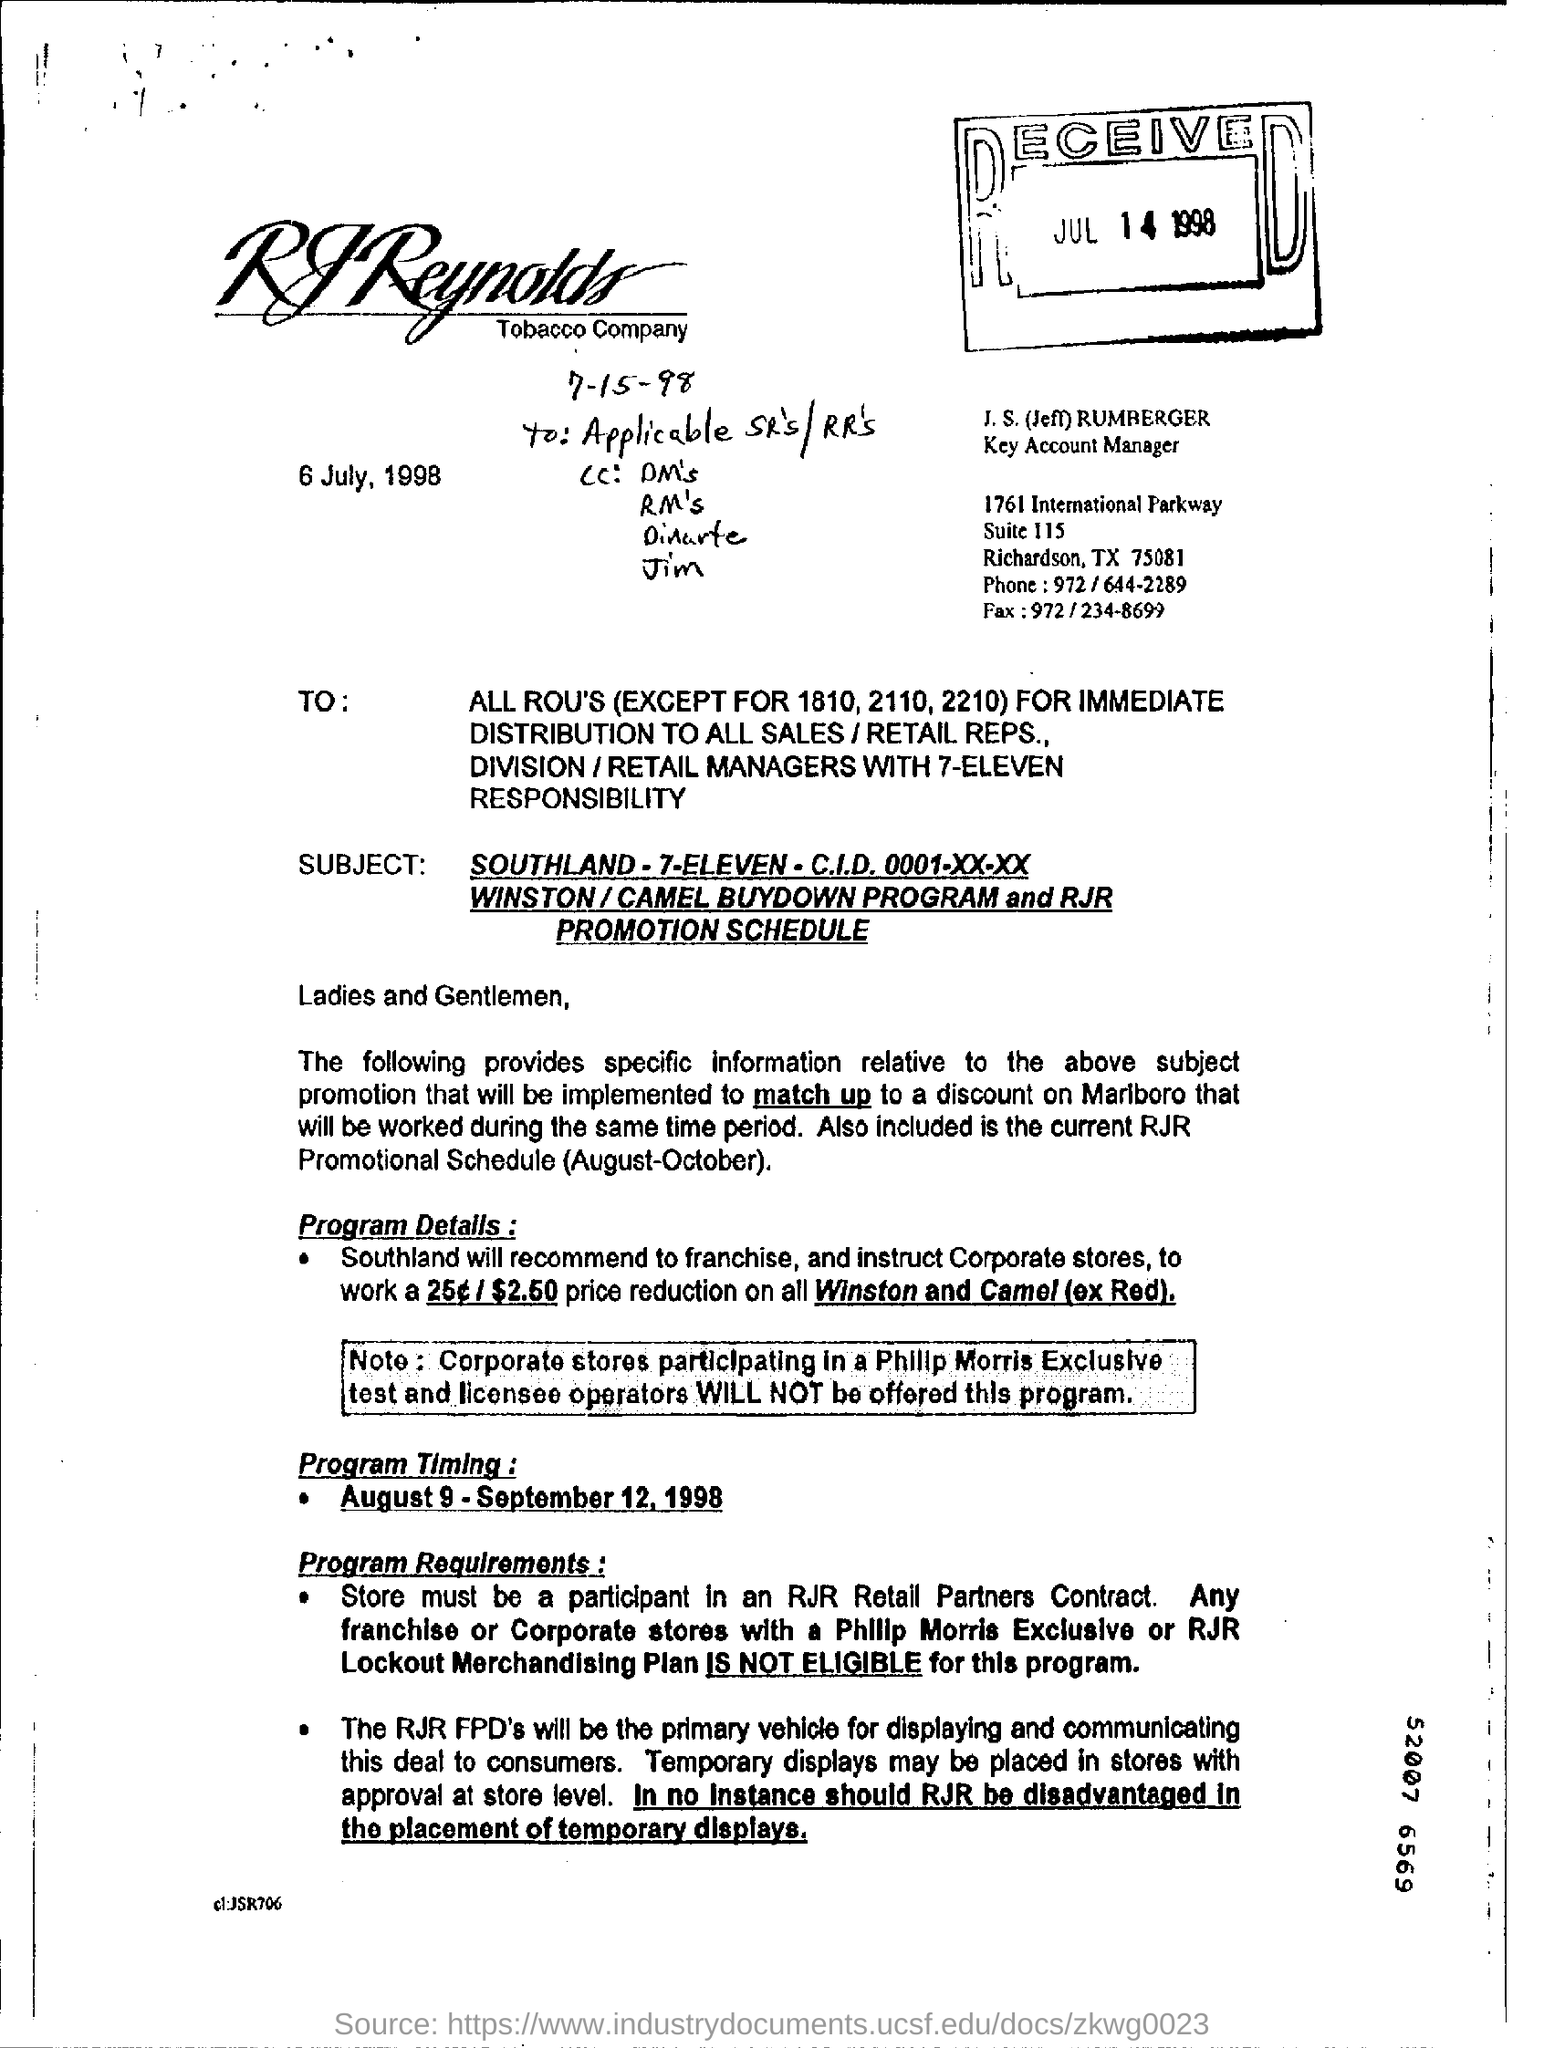Identify some key points in this picture. What is the nine-digit number that you mentioned? It is 52007 6569... Jeff Rumberger is a key account manager with the designation of J.S. The date mentioned is 6 July, 1998. 